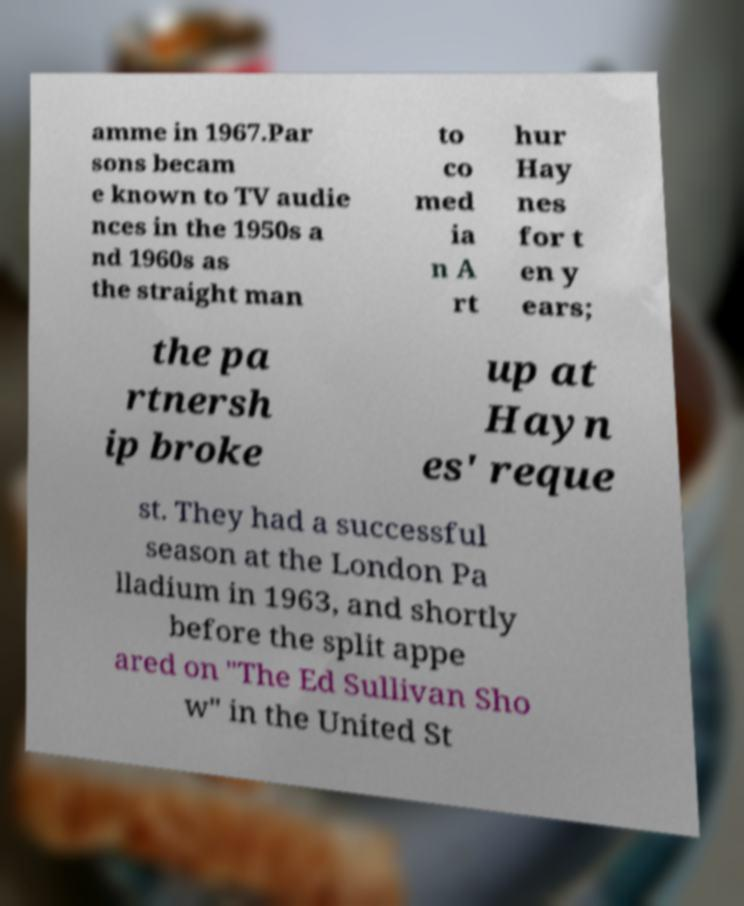Can you read and provide the text displayed in the image?This photo seems to have some interesting text. Can you extract and type it out for me? amme in 1967.Par sons becam e known to TV audie nces in the 1950s a nd 1960s as the straight man to co med ia n A rt hur Hay nes for t en y ears; the pa rtnersh ip broke up at Hayn es' reque st. They had a successful season at the London Pa lladium in 1963, and shortly before the split appe ared on "The Ed Sullivan Sho w" in the United St 